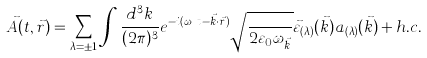<formula> <loc_0><loc_0><loc_500><loc_500>\vec { A } ( t , \vec { r } ) = \sum _ { \lambda = \pm 1 } \int \frac { d ^ { 3 } k } { ( 2 \pi ) ^ { 3 } } e ^ { - i ( \omega _ { \vec { k } } t - \vec { k } \cdot \vec { r } ) } \sqrt { \frac { } { 2 \varepsilon _ { 0 } \omega _ { \vec { k } } } } \vec { \varepsilon } _ { ( \lambda ) } ( \vec { k } ) a _ { ( \lambda ) } ( \vec { k } ) + h . c .</formula> 